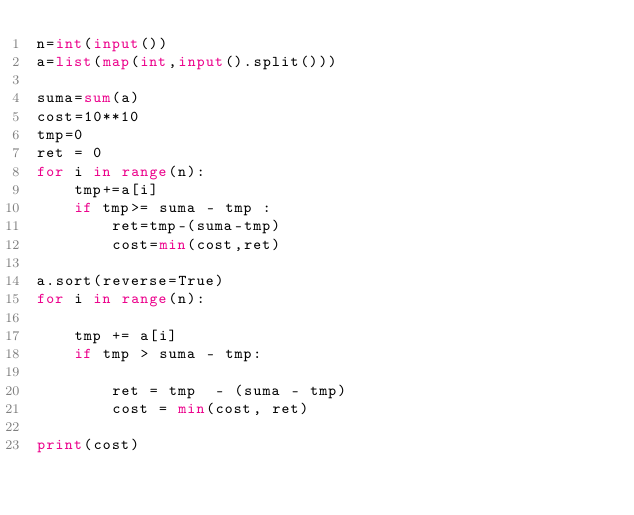Convert code to text. <code><loc_0><loc_0><loc_500><loc_500><_Python_>n=int(input())
a=list(map(int,input().split()))

suma=sum(a)
cost=10**10
tmp=0
ret = 0
for i in range(n):
    tmp+=a[i]
    if tmp>= suma - tmp :
        ret=tmp-(suma-tmp)
        cost=min(cost,ret)

a.sort(reverse=True)
for i in range(n):

    tmp += a[i]
    if tmp > suma - tmp:

        ret = tmp  - (suma - tmp)
        cost = min(cost, ret)

print(cost)


</code> 